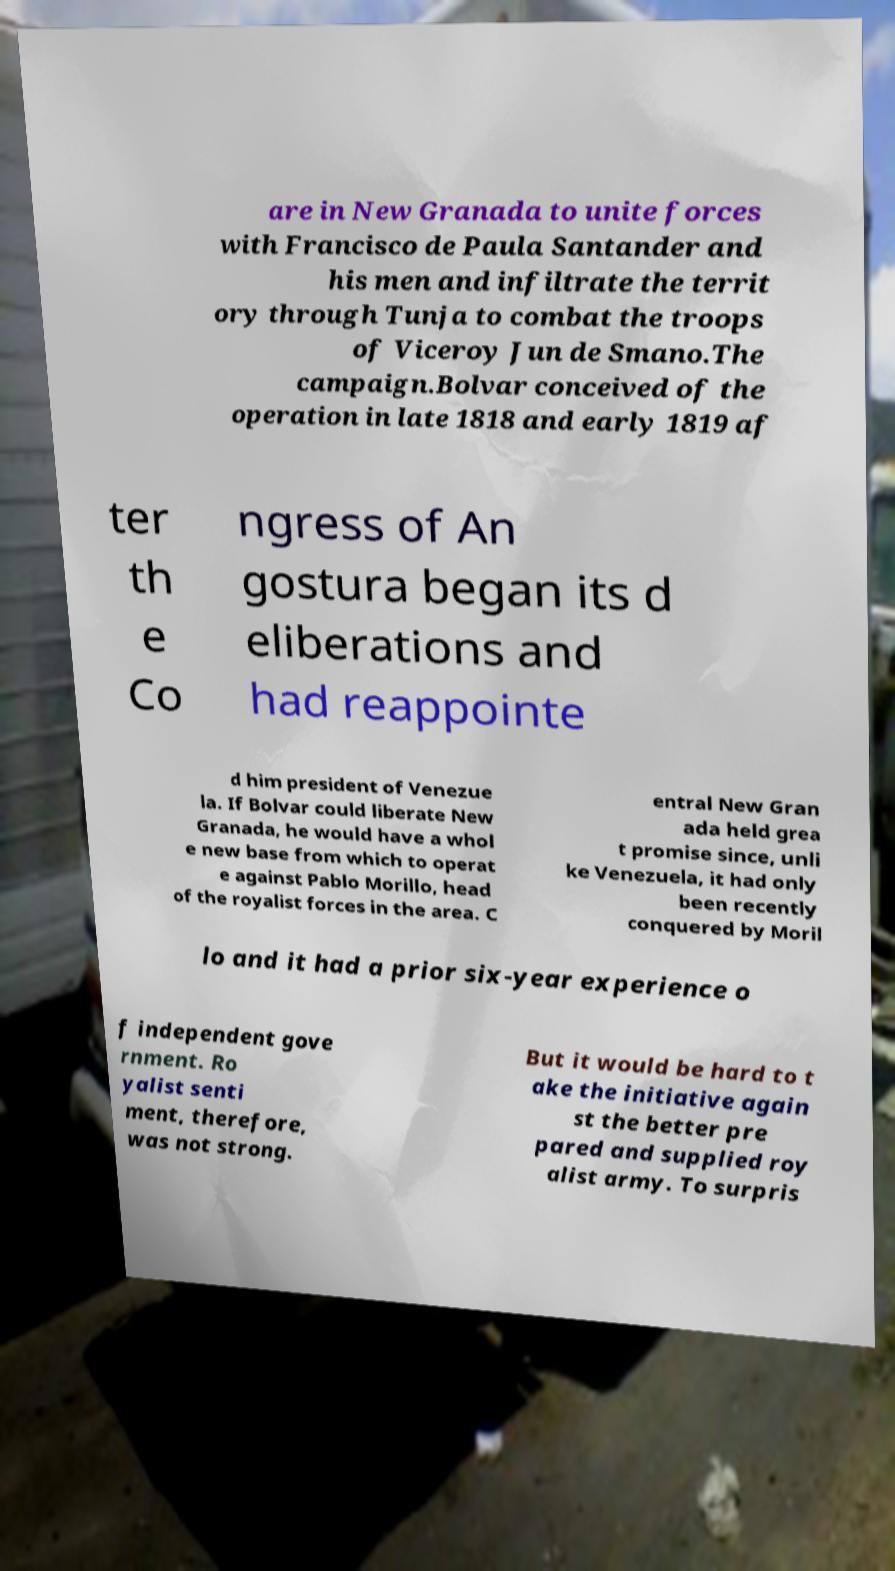Please read and relay the text visible in this image. What does it say? are in New Granada to unite forces with Francisco de Paula Santander and his men and infiltrate the territ ory through Tunja to combat the troops of Viceroy Jun de Smano.The campaign.Bolvar conceived of the operation in late 1818 and early 1819 af ter th e Co ngress of An gostura began its d eliberations and had reappointe d him president of Venezue la. If Bolvar could liberate New Granada, he would have a whol e new base from which to operat e against Pablo Morillo, head of the royalist forces in the area. C entral New Gran ada held grea t promise since, unli ke Venezuela, it had only been recently conquered by Moril lo and it had a prior six-year experience o f independent gove rnment. Ro yalist senti ment, therefore, was not strong. But it would be hard to t ake the initiative again st the better pre pared and supplied roy alist army. To surpris 